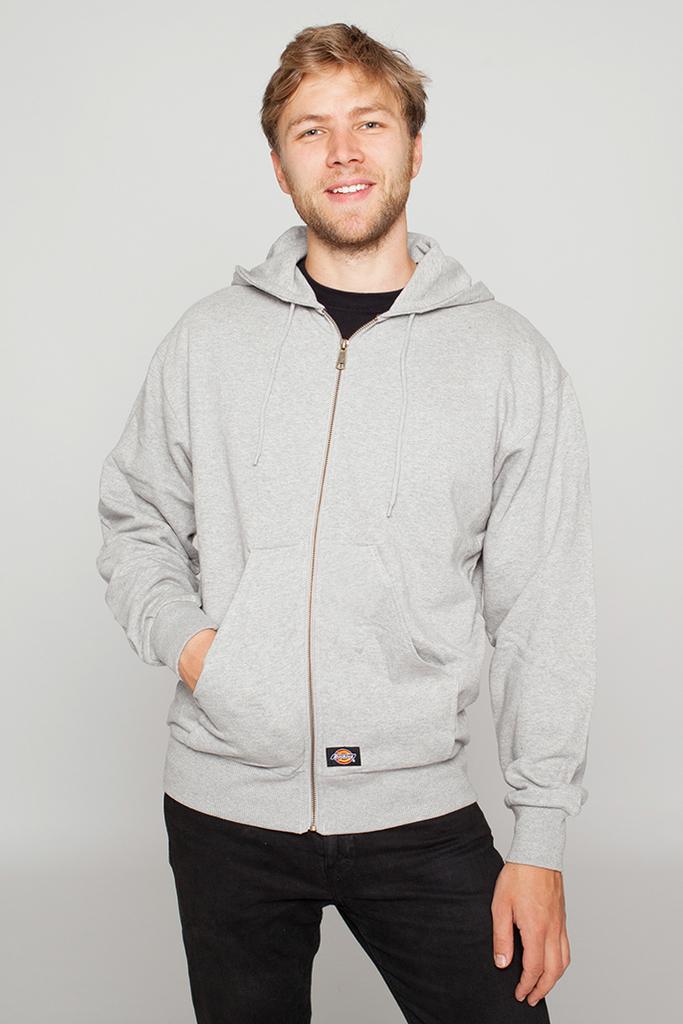Describe this image in one or two sentences. In the center of the image we can see a man standing and smiling. In the background there is a wall. 